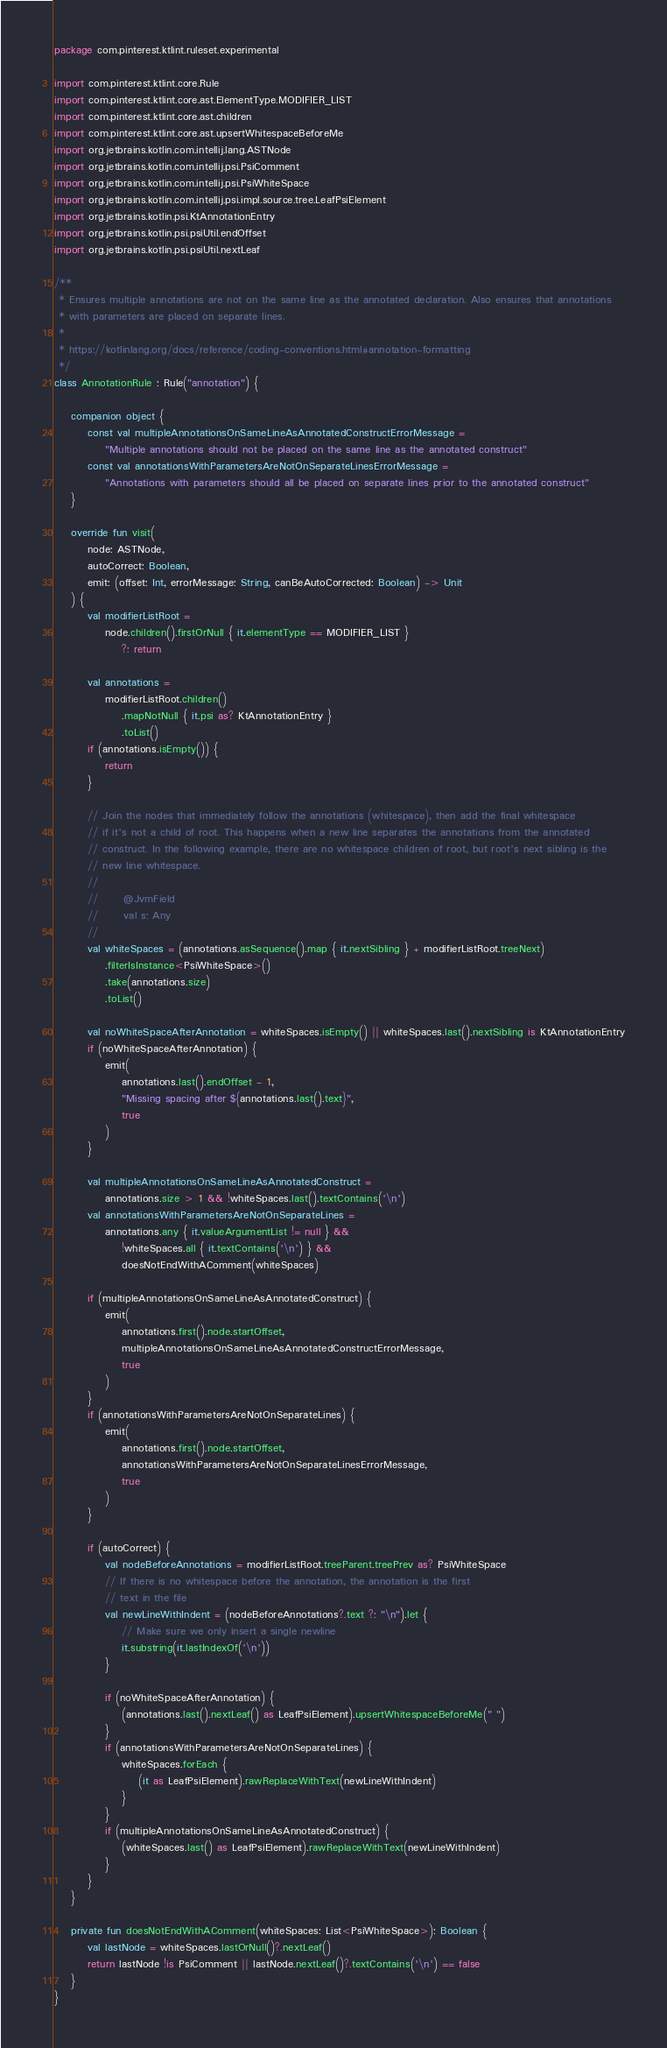Convert code to text. <code><loc_0><loc_0><loc_500><loc_500><_Kotlin_>package com.pinterest.ktlint.ruleset.experimental

import com.pinterest.ktlint.core.Rule
import com.pinterest.ktlint.core.ast.ElementType.MODIFIER_LIST
import com.pinterest.ktlint.core.ast.children
import com.pinterest.ktlint.core.ast.upsertWhitespaceBeforeMe
import org.jetbrains.kotlin.com.intellij.lang.ASTNode
import org.jetbrains.kotlin.com.intellij.psi.PsiComment
import org.jetbrains.kotlin.com.intellij.psi.PsiWhiteSpace
import org.jetbrains.kotlin.com.intellij.psi.impl.source.tree.LeafPsiElement
import org.jetbrains.kotlin.psi.KtAnnotationEntry
import org.jetbrains.kotlin.psi.psiUtil.endOffset
import org.jetbrains.kotlin.psi.psiUtil.nextLeaf

/**
 * Ensures multiple annotations are not on the same line as the annotated declaration. Also ensures that annotations
 * with parameters are placed on separate lines.
 *
 * https://kotlinlang.org/docs/reference/coding-conventions.html#annotation-formatting
 */
class AnnotationRule : Rule("annotation") {

    companion object {
        const val multipleAnnotationsOnSameLineAsAnnotatedConstructErrorMessage =
            "Multiple annotations should not be placed on the same line as the annotated construct"
        const val annotationsWithParametersAreNotOnSeparateLinesErrorMessage =
            "Annotations with parameters should all be placed on separate lines prior to the annotated construct"
    }

    override fun visit(
        node: ASTNode,
        autoCorrect: Boolean,
        emit: (offset: Int, errorMessage: String, canBeAutoCorrected: Boolean) -> Unit
    ) {
        val modifierListRoot =
            node.children().firstOrNull { it.elementType == MODIFIER_LIST }
                ?: return

        val annotations =
            modifierListRoot.children()
                .mapNotNull { it.psi as? KtAnnotationEntry }
                .toList()
        if (annotations.isEmpty()) {
            return
        }

        // Join the nodes that immediately follow the annotations (whitespace), then add the final whitespace
        // if it's not a child of root. This happens when a new line separates the annotations from the annotated
        // construct. In the following example, there are no whitespace children of root, but root's next sibling is the
        // new line whitespace.
        //
        //      @JvmField
        //      val s: Any
        //
        val whiteSpaces = (annotations.asSequence().map { it.nextSibling } + modifierListRoot.treeNext)
            .filterIsInstance<PsiWhiteSpace>()
            .take(annotations.size)
            .toList()

        val noWhiteSpaceAfterAnnotation = whiteSpaces.isEmpty() || whiteSpaces.last().nextSibling is KtAnnotationEntry
        if (noWhiteSpaceAfterAnnotation) {
            emit(
                annotations.last().endOffset - 1,
                "Missing spacing after ${annotations.last().text}",
                true
            )
        }

        val multipleAnnotationsOnSameLineAsAnnotatedConstruct =
            annotations.size > 1 && !whiteSpaces.last().textContains('\n')
        val annotationsWithParametersAreNotOnSeparateLines =
            annotations.any { it.valueArgumentList != null } &&
                !whiteSpaces.all { it.textContains('\n') } &&
                doesNotEndWithAComment(whiteSpaces)

        if (multipleAnnotationsOnSameLineAsAnnotatedConstruct) {
            emit(
                annotations.first().node.startOffset,
                multipleAnnotationsOnSameLineAsAnnotatedConstructErrorMessage,
                true
            )
        }
        if (annotationsWithParametersAreNotOnSeparateLines) {
            emit(
                annotations.first().node.startOffset,
                annotationsWithParametersAreNotOnSeparateLinesErrorMessage,
                true
            )
        }

        if (autoCorrect) {
            val nodeBeforeAnnotations = modifierListRoot.treeParent.treePrev as? PsiWhiteSpace
            // If there is no whitespace before the annotation, the annotation is the first
            // text in the file
            val newLineWithIndent = (nodeBeforeAnnotations?.text ?: "\n").let {
                // Make sure we only insert a single newline
                it.substring(it.lastIndexOf('\n'))
            }

            if (noWhiteSpaceAfterAnnotation) {
                (annotations.last().nextLeaf() as LeafPsiElement).upsertWhitespaceBeforeMe(" ")
            }
            if (annotationsWithParametersAreNotOnSeparateLines) {
                whiteSpaces.forEach {
                    (it as LeafPsiElement).rawReplaceWithText(newLineWithIndent)
                }
            }
            if (multipleAnnotationsOnSameLineAsAnnotatedConstruct) {
                (whiteSpaces.last() as LeafPsiElement).rawReplaceWithText(newLineWithIndent)
            }
        }
    }

    private fun doesNotEndWithAComment(whiteSpaces: List<PsiWhiteSpace>): Boolean {
        val lastNode = whiteSpaces.lastOrNull()?.nextLeaf()
        return lastNode !is PsiComment || lastNode.nextLeaf()?.textContains('\n') == false
    }
}
</code> 